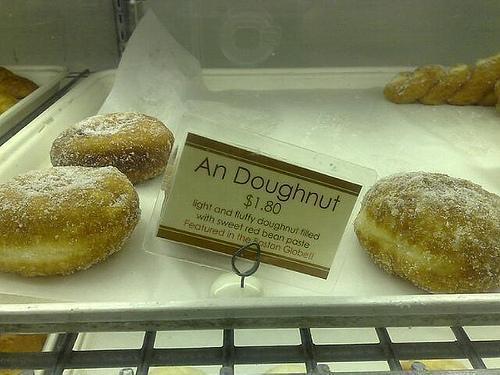How many donuts in the tray?
Give a very brief answer. 4. How many donuts are there?
Give a very brief answer. 4. 